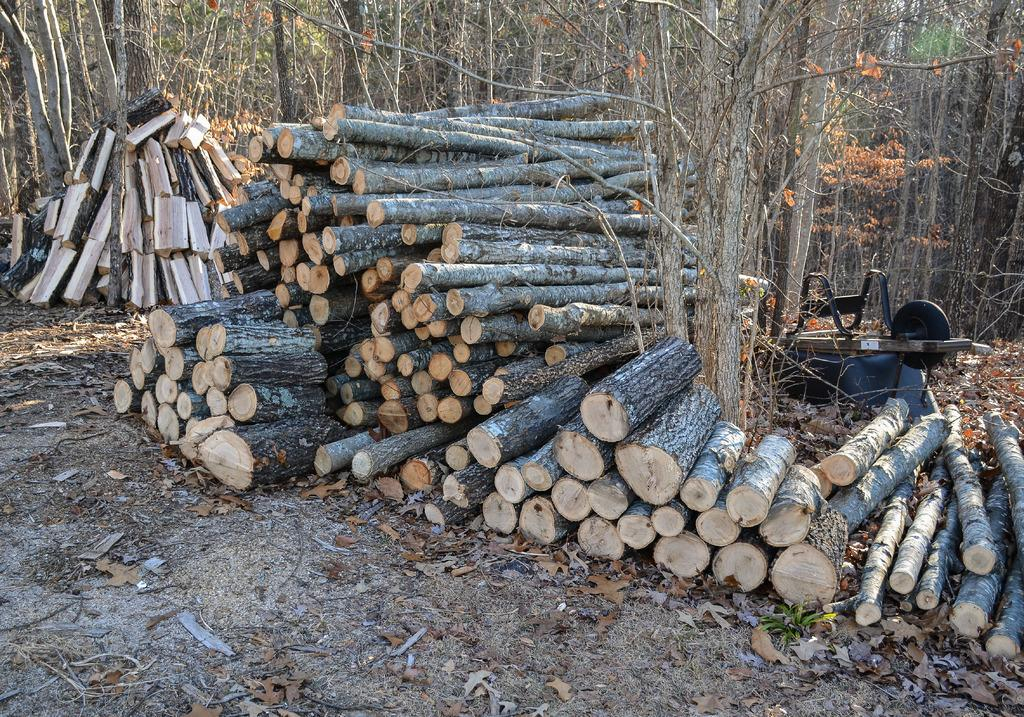What is on the surface in the image? There are wooden logs on the surface in the image. What can be seen behind the wooden logs? There is a machine behind the wooden logs. What type of natural environment is visible in the background of the image? Trees are present in the background of the image. Are there any lizards playing on the playground in the image? There is no playground present in the image, and therefore no lizards can be seen playing on it. What type of authority figure is overseeing the wooden logs in the image? There is no authority figure present in the image; it only shows wooden logs and a machine in the background. 